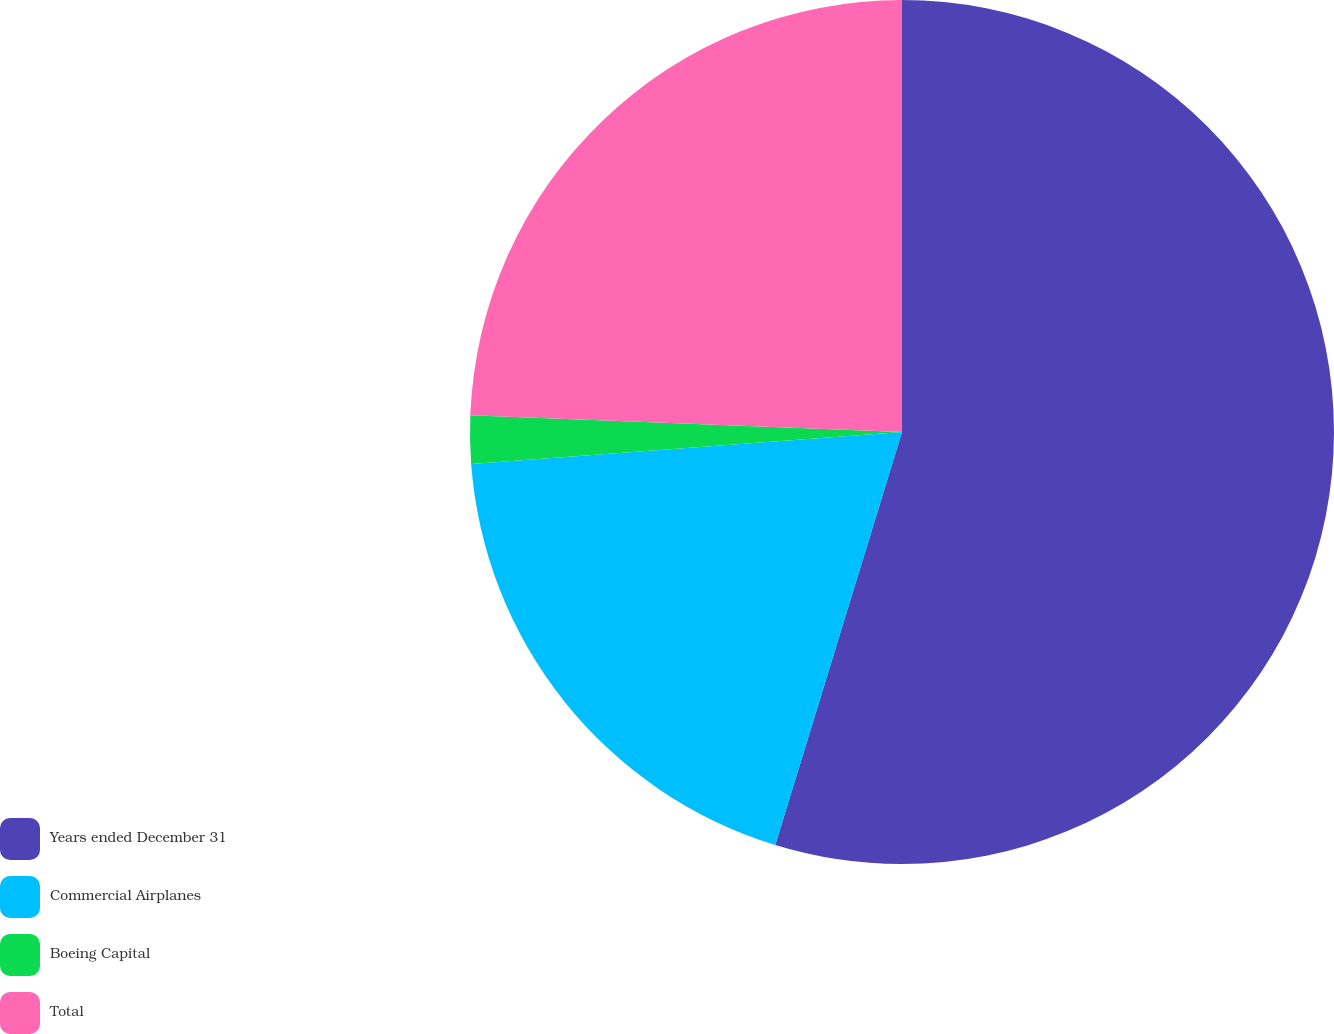<chart> <loc_0><loc_0><loc_500><loc_500><pie_chart><fcel>Years ended December 31<fcel>Commercial Airplanes<fcel>Boeing Capital<fcel>Total<nl><fcel>54.74%<fcel>19.08%<fcel>1.8%<fcel>24.38%<nl></chart> 